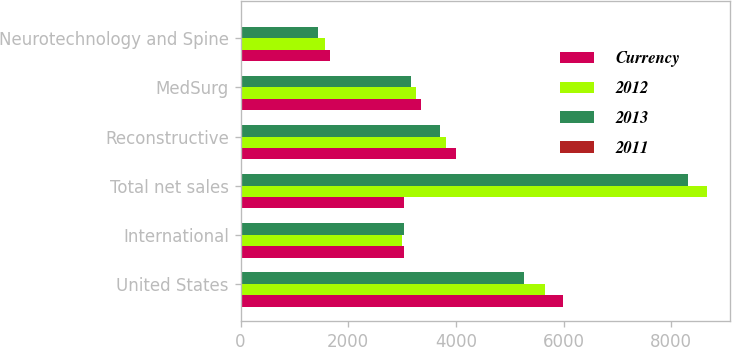Convert chart. <chart><loc_0><loc_0><loc_500><loc_500><stacked_bar_chart><ecel><fcel>United States<fcel>International<fcel>Total net sales<fcel>Reconstructive<fcel>MedSurg<fcel>Neurotechnology and Spine<nl><fcel>Currency<fcel>5984<fcel>3037<fcel>3038<fcel>4004<fcel>3359<fcel>1658<nl><fcel>2012<fcel>5658<fcel>2999<fcel>8657<fcel>3823<fcel>3265<fcel>1569<nl><fcel>2013<fcel>5269<fcel>3038<fcel>8307<fcel>3710<fcel>3160<fcel>1437<nl><fcel>2011<fcel>5.8<fcel>1.3<fcel>4.2<fcel>4.8<fcel>2.9<fcel>5.6<nl></chart> 